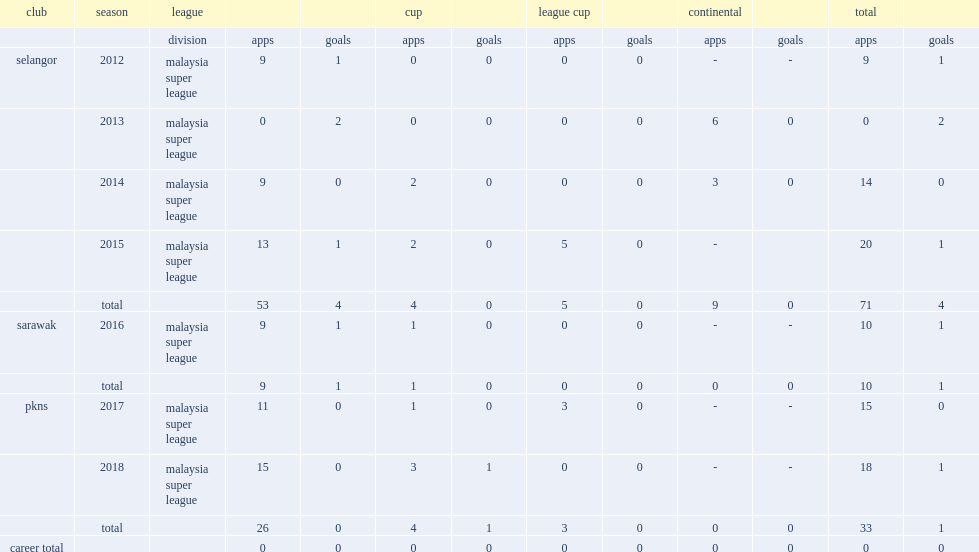Which club did gurusamy play for in 2012? Selangor. 